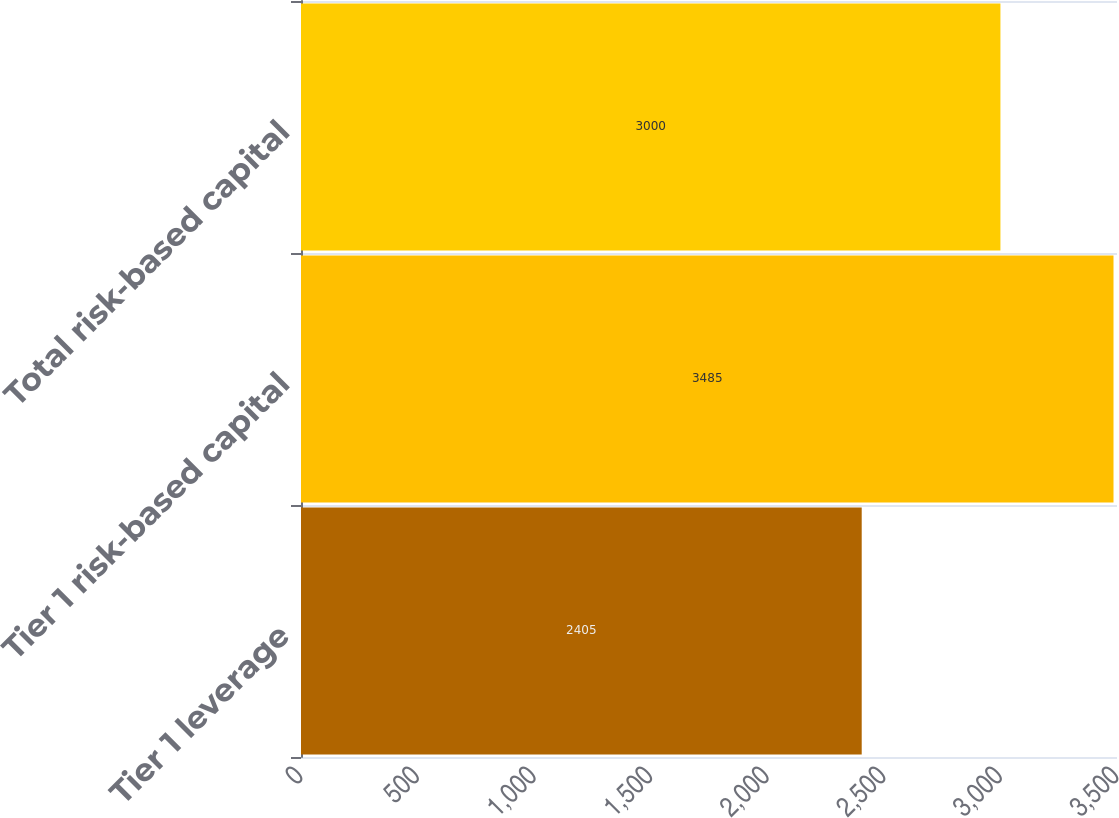Convert chart. <chart><loc_0><loc_0><loc_500><loc_500><bar_chart><fcel>Tier 1 leverage<fcel>Tier 1 risk-based capital<fcel>Total risk-based capital<nl><fcel>2405<fcel>3485<fcel>3000<nl></chart> 